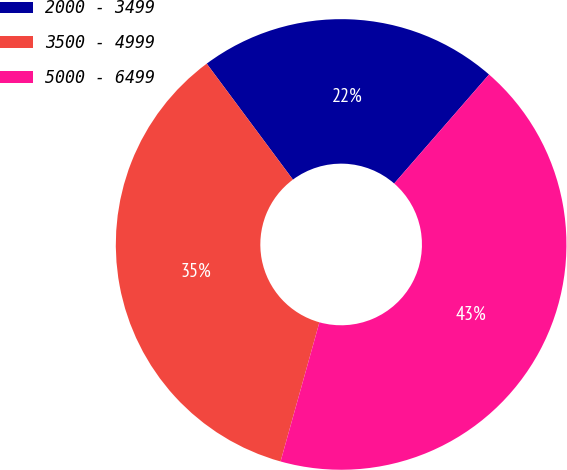Convert chart to OTSL. <chart><loc_0><loc_0><loc_500><loc_500><pie_chart><fcel>2000 - 3499<fcel>3500 - 4999<fcel>5000 - 6499<nl><fcel>21.57%<fcel>35.49%<fcel>42.93%<nl></chart> 